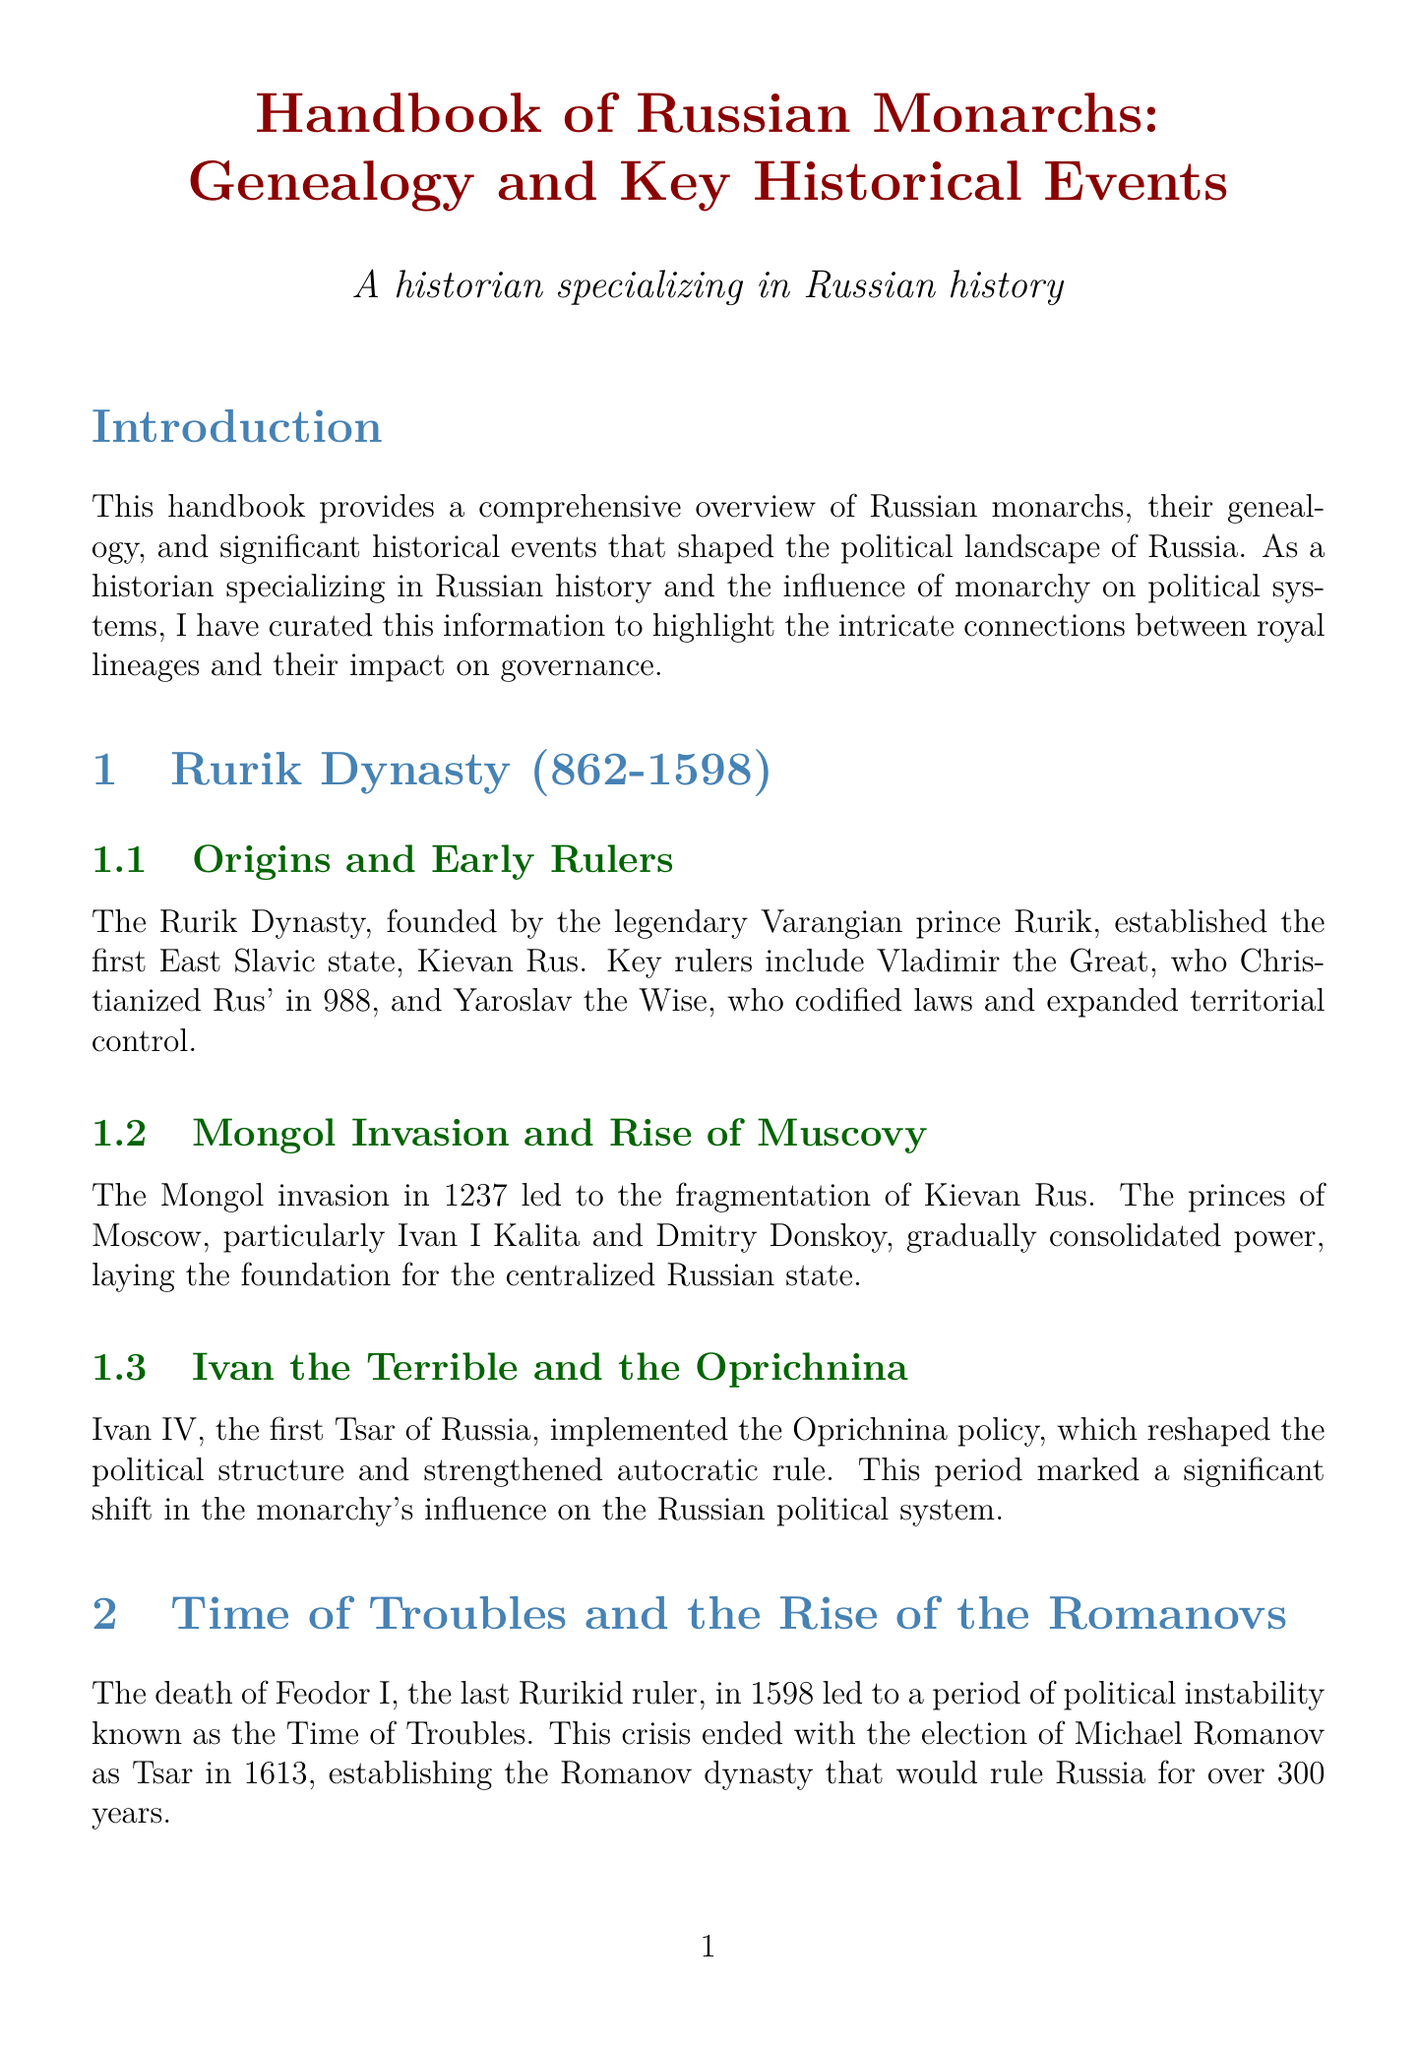What is the founding year of the Rurik Dynasty? The Rurik Dynasty is established in the year 862.
Answer: 862 Who was the first Tsar of Russia? The document states that Ivan IV is recognized as the first Tsar of Russia.
Answer: Ivan IV What significant event ended the Time of Troubles? The election of Michael Romanov as Tsar in 1613 ended the Time of Troubles.
Answer: Election of Michael Romanov Which ruler implemented the Oprichnina policy? Ivan IV is noted for implementing the Oprichnina policy.
Answer: Ivan IV What major reform did Alexander II enact in 1861? Alexander II's emancipation of the serfs in 1861 is highlighted as a significant reform.
Answer: Emancipation of the serfs What is the time span of the Romanov Dynasty? The Romanov Dynasty ruled from 1613 to 1917.
Answer: 1613-1917 What does the section on the Legacy of Russian Monarchy discuss? It covers the monarchy's profound and long-lasting influence on the political system.
Answer: Influence on political system Who codified laws and expanded territorial control in Kievan Rus? Yaroslav the Wise is credited with codifying laws and expanding territorial control.
Answer: Yaroslav the Wise What key reform characterized Peter the Great's reign? His reforms modernized Russia and established it as a European power.
Answer: Modernization of Russia 